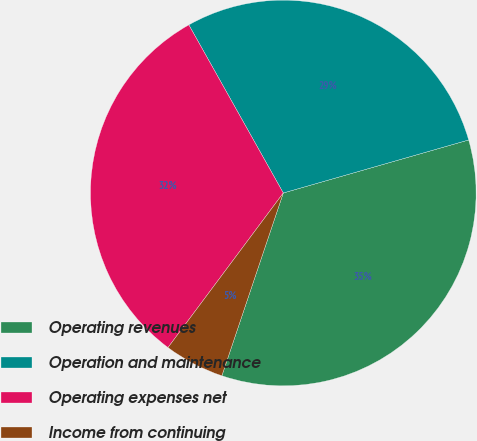Convert chart to OTSL. <chart><loc_0><loc_0><loc_500><loc_500><pie_chart><fcel>Operating revenues<fcel>Operation and maintenance<fcel>Operating expenses net<fcel>Income from continuing<nl><fcel>34.59%<fcel>28.71%<fcel>31.65%<fcel>5.04%<nl></chart> 